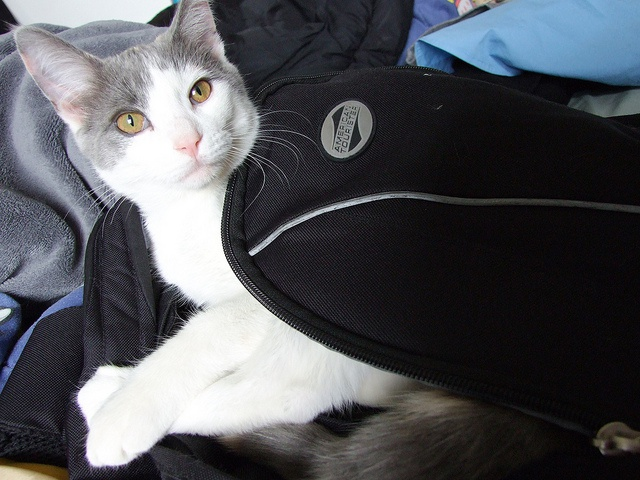Describe the objects in this image and their specific colors. I can see handbag in black, gray, and darkgray tones and cat in black, white, darkgray, and gray tones in this image. 